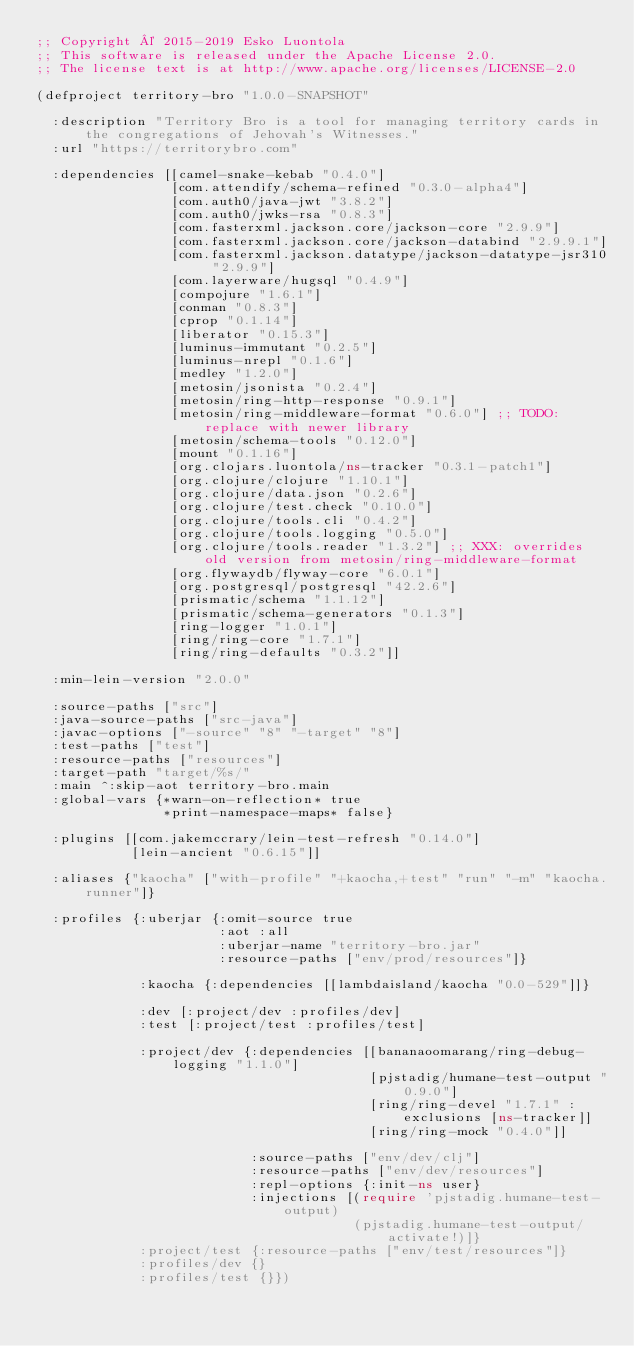Convert code to text. <code><loc_0><loc_0><loc_500><loc_500><_Clojure_>;; Copyright © 2015-2019 Esko Luontola
;; This software is released under the Apache License 2.0.
;; The license text is at http://www.apache.org/licenses/LICENSE-2.0

(defproject territory-bro "1.0.0-SNAPSHOT"

  :description "Territory Bro is a tool for managing territory cards in the congregations of Jehovah's Witnesses."
  :url "https://territorybro.com"

  :dependencies [[camel-snake-kebab "0.4.0"]
                 [com.attendify/schema-refined "0.3.0-alpha4"]
                 [com.auth0/java-jwt "3.8.2"]
                 [com.auth0/jwks-rsa "0.8.3"]
                 [com.fasterxml.jackson.core/jackson-core "2.9.9"]
                 [com.fasterxml.jackson.core/jackson-databind "2.9.9.1"]
                 [com.fasterxml.jackson.datatype/jackson-datatype-jsr310 "2.9.9"]
                 [com.layerware/hugsql "0.4.9"]
                 [compojure "1.6.1"]
                 [conman "0.8.3"]
                 [cprop "0.1.14"]
                 [liberator "0.15.3"]
                 [luminus-immutant "0.2.5"]
                 [luminus-nrepl "0.1.6"]
                 [medley "1.2.0"]
                 [metosin/jsonista "0.2.4"]
                 [metosin/ring-http-response "0.9.1"]
                 [metosin/ring-middleware-format "0.6.0"] ;; TODO: replace with newer library
                 [metosin/schema-tools "0.12.0"]
                 [mount "0.1.16"]
                 [org.clojars.luontola/ns-tracker "0.3.1-patch1"]
                 [org.clojure/clojure "1.10.1"]
                 [org.clojure/data.json "0.2.6"]
                 [org.clojure/test.check "0.10.0"]
                 [org.clojure/tools.cli "0.4.2"]
                 [org.clojure/tools.logging "0.5.0"]
                 [org.clojure/tools.reader "1.3.2"] ;; XXX: overrides old version from metosin/ring-middleware-format
                 [org.flywaydb/flyway-core "6.0.1"]
                 [org.postgresql/postgresql "42.2.6"]
                 [prismatic/schema "1.1.12"]
                 [prismatic/schema-generators "0.1.3"]
                 [ring-logger "1.0.1"]
                 [ring/ring-core "1.7.1"]
                 [ring/ring-defaults "0.3.2"]]

  :min-lein-version "2.0.0"

  :source-paths ["src"]
  :java-source-paths ["src-java"]
  :javac-options ["-source" "8" "-target" "8"]
  :test-paths ["test"]
  :resource-paths ["resources"]
  :target-path "target/%s/"
  :main ^:skip-aot territory-bro.main
  :global-vars {*warn-on-reflection* true
                *print-namespace-maps* false}

  :plugins [[com.jakemccrary/lein-test-refresh "0.14.0"]
            [lein-ancient "0.6.15"]]

  :aliases {"kaocha" ["with-profile" "+kaocha,+test" "run" "-m" "kaocha.runner"]}

  :profiles {:uberjar {:omit-source true
                       :aot :all
                       :uberjar-name "territory-bro.jar"
                       :resource-paths ["env/prod/resources"]}

             :kaocha {:dependencies [[lambdaisland/kaocha "0.0-529"]]}

             :dev [:project/dev :profiles/dev]
             :test [:project/test :profiles/test]

             :project/dev {:dependencies [[bananaoomarang/ring-debug-logging "1.1.0"]
                                          [pjstadig/humane-test-output "0.9.0"]
                                          [ring/ring-devel "1.7.1" :exclusions [ns-tracker]]
                                          [ring/ring-mock "0.4.0"]]

                           :source-paths ["env/dev/clj"]
                           :resource-paths ["env/dev/resources"]
                           :repl-options {:init-ns user}
                           :injections [(require 'pjstadig.humane-test-output)
                                        (pjstadig.humane-test-output/activate!)]}
             :project/test {:resource-paths ["env/test/resources"]}
             :profiles/dev {}
             :profiles/test {}})
</code> 